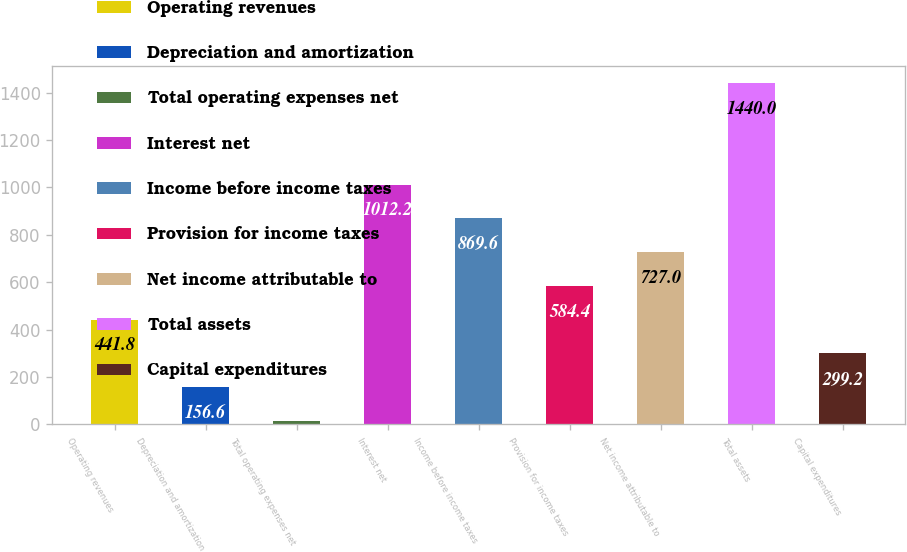<chart> <loc_0><loc_0><loc_500><loc_500><bar_chart><fcel>Operating revenues<fcel>Depreciation and amortization<fcel>Total operating expenses net<fcel>Interest net<fcel>Income before income taxes<fcel>Provision for income taxes<fcel>Net income attributable to<fcel>Total assets<fcel>Capital expenditures<nl><fcel>441.8<fcel>156.6<fcel>14<fcel>1012.2<fcel>869.6<fcel>584.4<fcel>727<fcel>1440<fcel>299.2<nl></chart> 